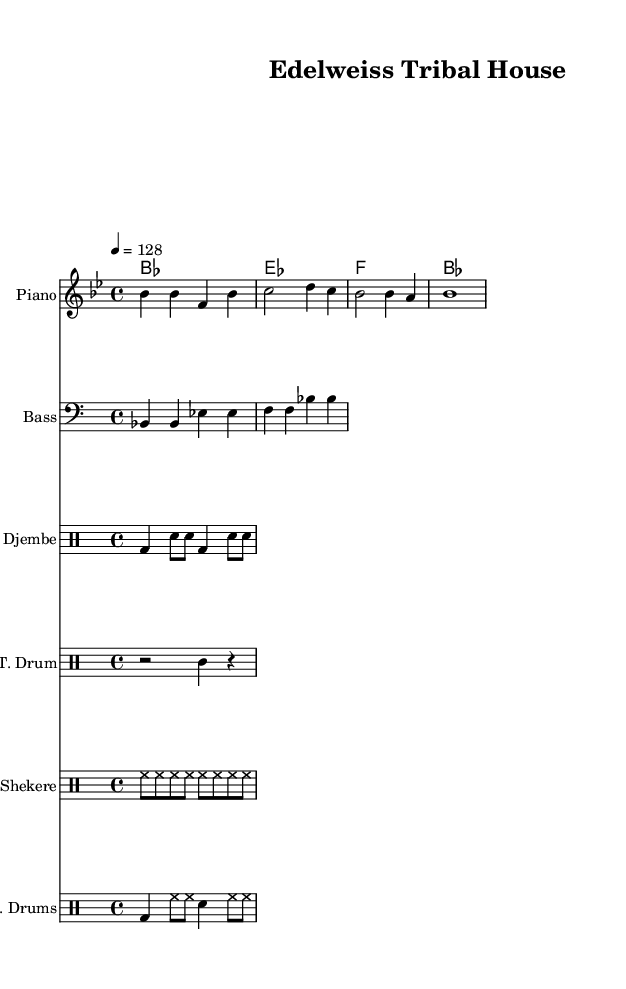What is the key signature of this music? The key signature is B flat major, which has two flats (B flat and E flat). This can be identified by looking at the beginning of the staff where the flat symbols are placed.
Answer: B flat major What is the time signature of this music? The time signature is 4/4, which indicates that there are four beats in each measure and a quarter note receives one beat. This is evident from the "4/4" notation seen at the beginning of the piece.
Answer: 4/4 What is the tempo marking of the piece? The tempo marking is 128 beats per minute, indicated by the "4 = 128" tempo notation. This shows how fast the piece should be played, with each quarter note equating to 128 beats in one minute.
Answer: 128 How many measures are present in the melody? The melody consists of 6 measures, which can be counted by dividing the score into segments separated by the vertical bar lines. Each segment represents one measure.
Answer: 6 What instruments are used in this arrangement? The arrangement includes Piano, Bass, Djembe, Talking Drum, Shekere, and Electronic Drums, as indicated by the instrument names displayed at the start of each staff in the score.
Answer: Piano, Bass, Djembe, Talking Drum, Shekere, Electronic Drums Which percussion instrument is notated for bass clef? The bass clef is used for the Bass instrument in this score, as seen from the clef sign at the beginning of the bass staff. Other percussion instruments are notated on different staves with their respective percussion clefs.
Answer: Bass 